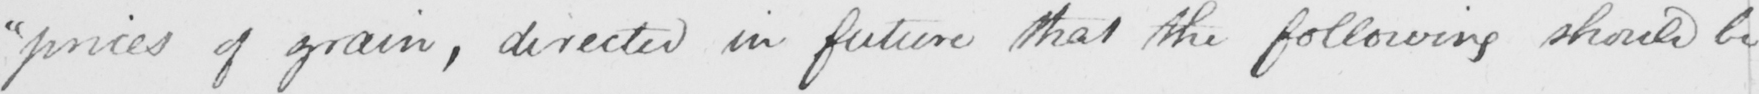Can you tell me what this handwritten text says? " prices of grain , directed in future that the following should be 